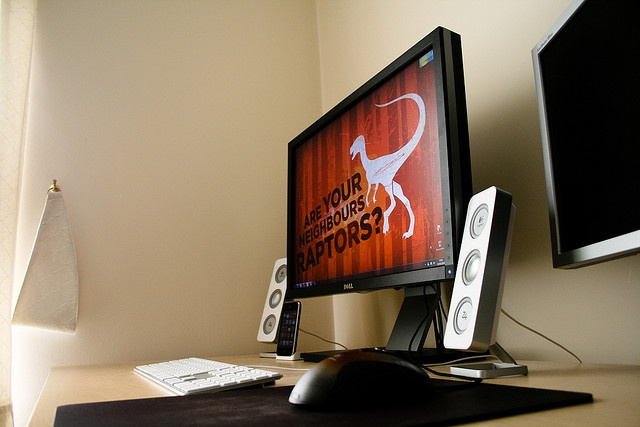Describe the objects in this image and their specific colors. I can see tv in beige, black, maroon, and brown tones, tv in beige, black, darkgray, lightgray, and gray tones, mouse in beige, black, lightgray, darkgray, and gray tones, keyboard in beige, lightgray, black, darkgray, and gray tones, and cell phone in beige, black, gray, and darkgreen tones in this image. 